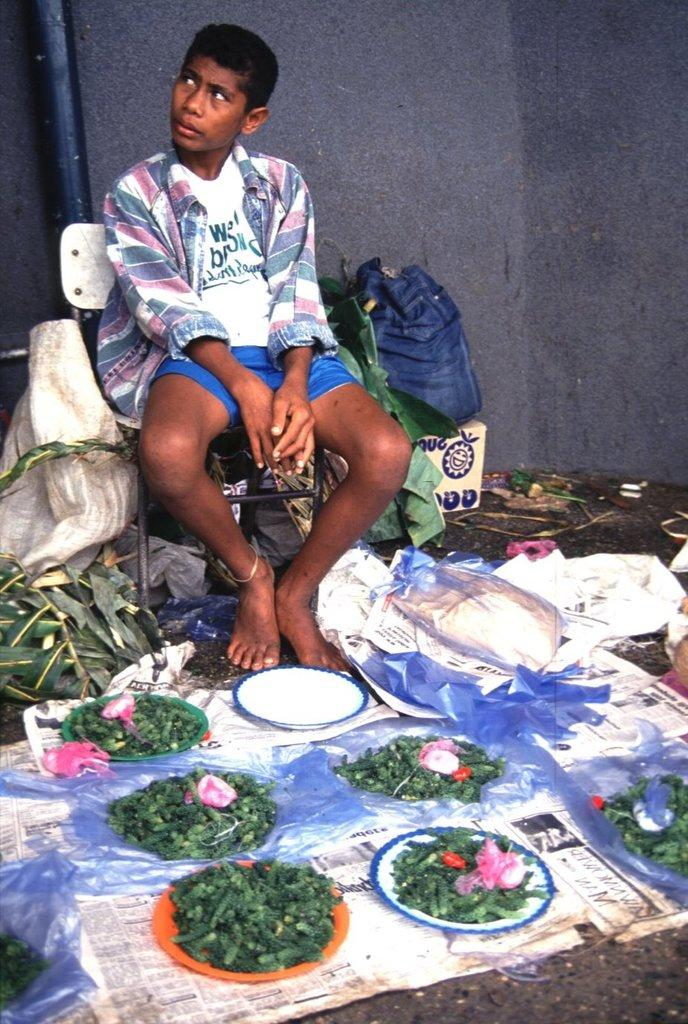What is the person in the image doing? There is a person sitting on a chair in the image. What type of vegetation can be seen in the image? There are leaves in the image. What type of stationery items are present in the image? There are papers in the image. Can you describe any other objects in the image? There are other unspecified objects in the image. What type of locket is the person holding in the image? There is no locket present in the image; the person is sitting on a chair, and there are leaves, papers, and other unspecified objects visible. 